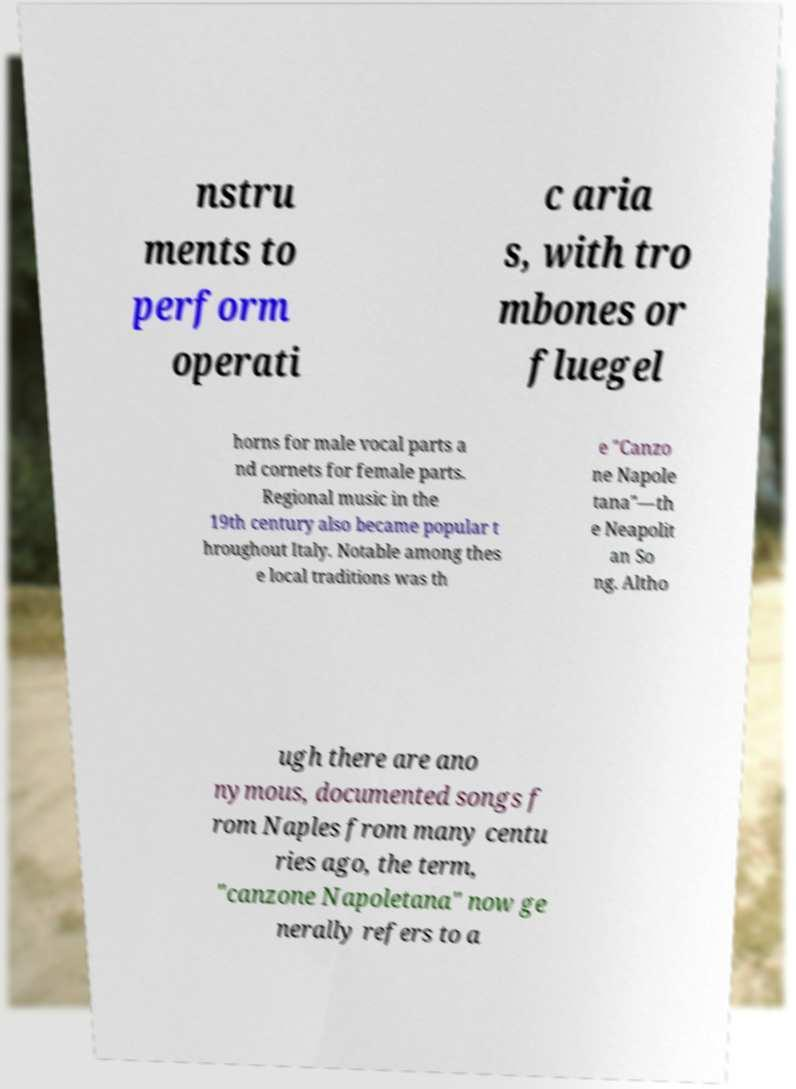Please read and relay the text visible in this image. What does it say? nstru ments to perform operati c aria s, with tro mbones or fluegel horns for male vocal parts a nd cornets for female parts. Regional music in the 19th century also became popular t hroughout Italy. Notable among thes e local traditions was th e "Canzo ne Napole tana"—th e Neapolit an So ng. Altho ugh there are ano nymous, documented songs f rom Naples from many centu ries ago, the term, "canzone Napoletana" now ge nerally refers to a 